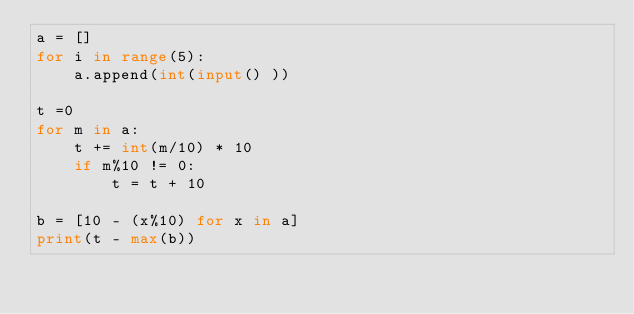<code> <loc_0><loc_0><loc_500><loc_500><_Python_>a = []
for i in range(5):
    a.append(int(input() )) 

t =0
for m in a:
    t += int(m/10) * 10
    if m%10 != 0:
        t = t + 10

b = [10 - (x%10) for x in a]
print(t - max(b))</code> 